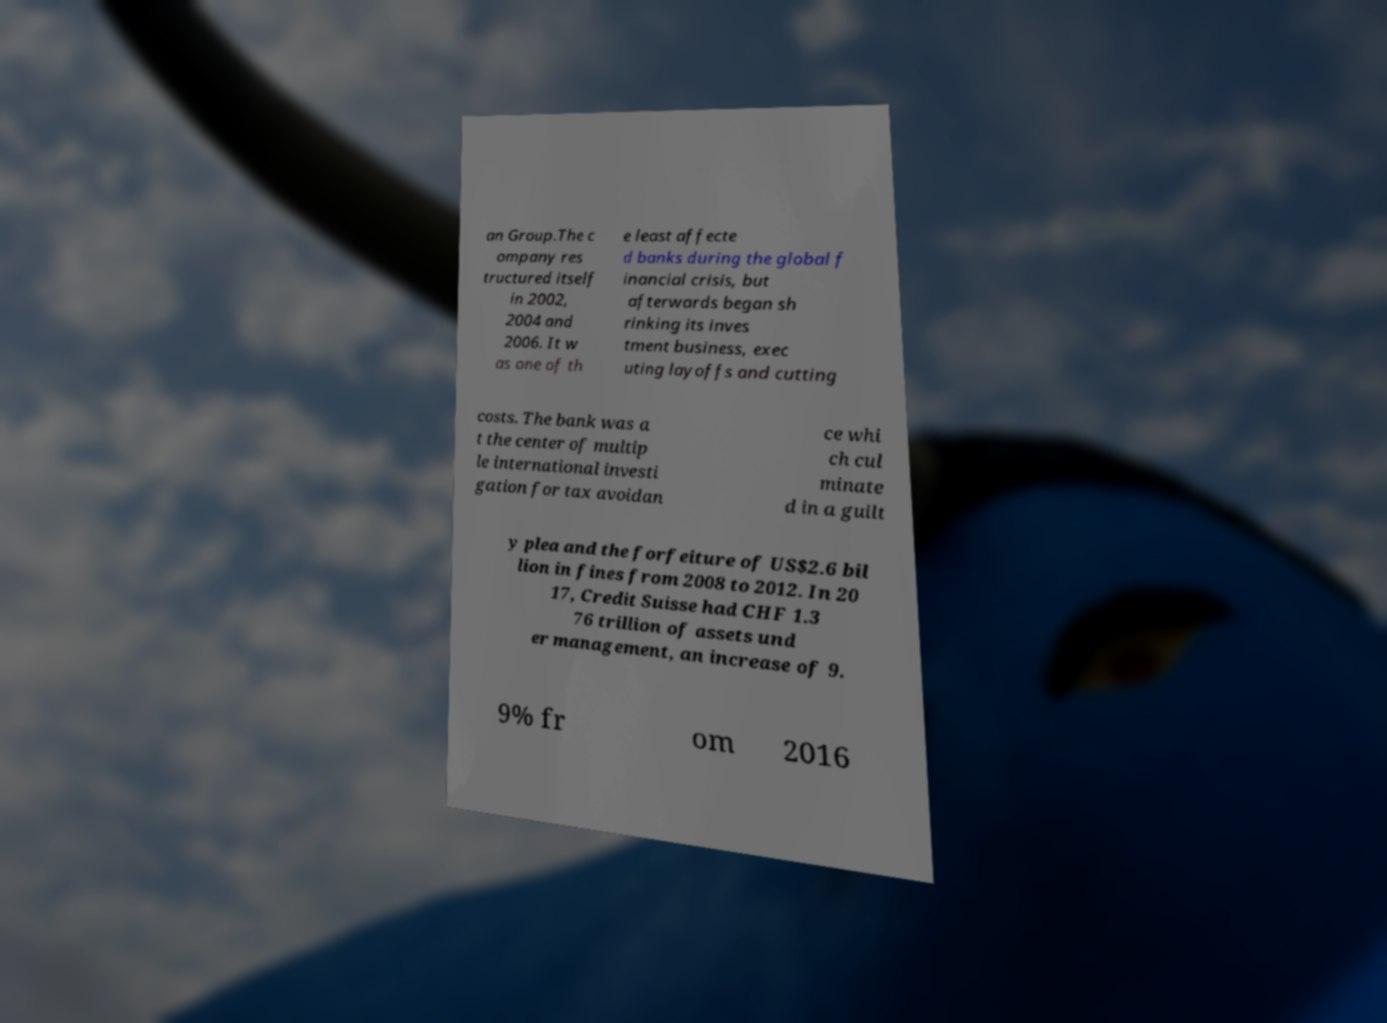Please read and relay the text visible in this image. What does it say? an Group.The c ompany res tructured itself in 2002, 2004 and 2006. It w as one of th e least affecte d banks during the global f inancial crisis, but afterwards began sh rinking its inves tment business, exec uting layoffs and cutting costs. The bank was a t the center of multip le international investi gation for tax avoidan ce whi ch cul minate d in a guilt y plea and the forfeiture of US$2.6 bil lion in fines from 2008 to 2012. In 20 17, Credit Suisse had CHF 1.3 76 trillion of assets und er management, an increase of 9. 9% fr om 2016 